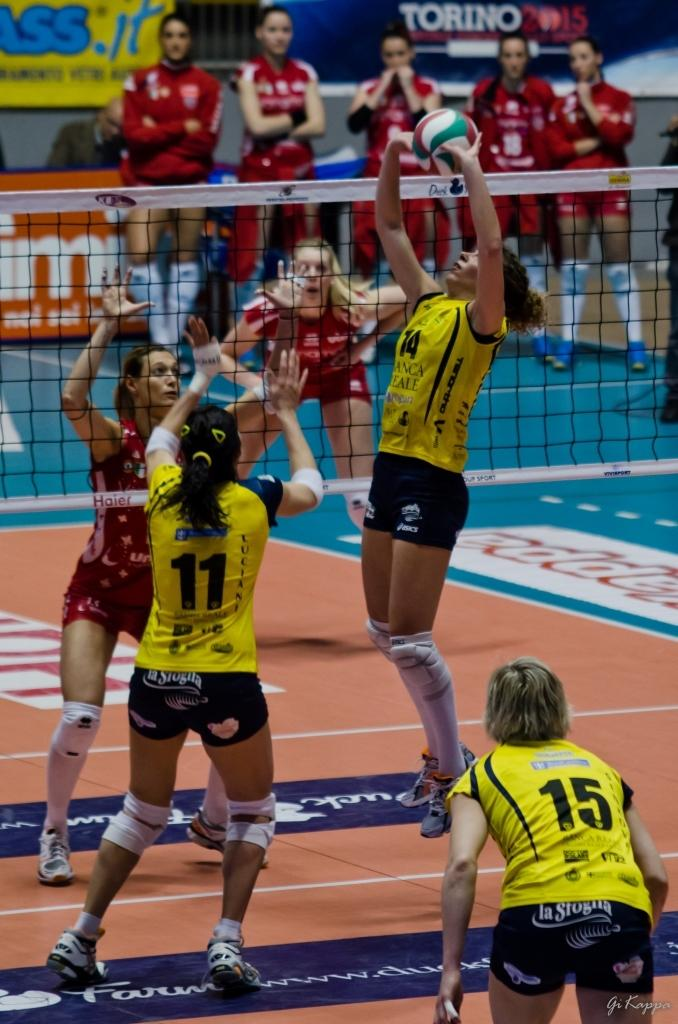What sport are the women players engaged in within the image? The women players are playing volleyball in the image. What separates the two teams in the game? There is a net in the image that separates the two teams. Can you describe the positions of some of the players in the image? Some players are standing on the back in the image. What else can be seen in the image besides the game? There are advertisement boards with text in the image. What type of jelly is being used to divide the teams in the image? There is no jelly present in the image; the teams are separated by a net. What kind of sheet is covering the volleyball court in the image? There is no sheet covering the volleyball court in the image. 